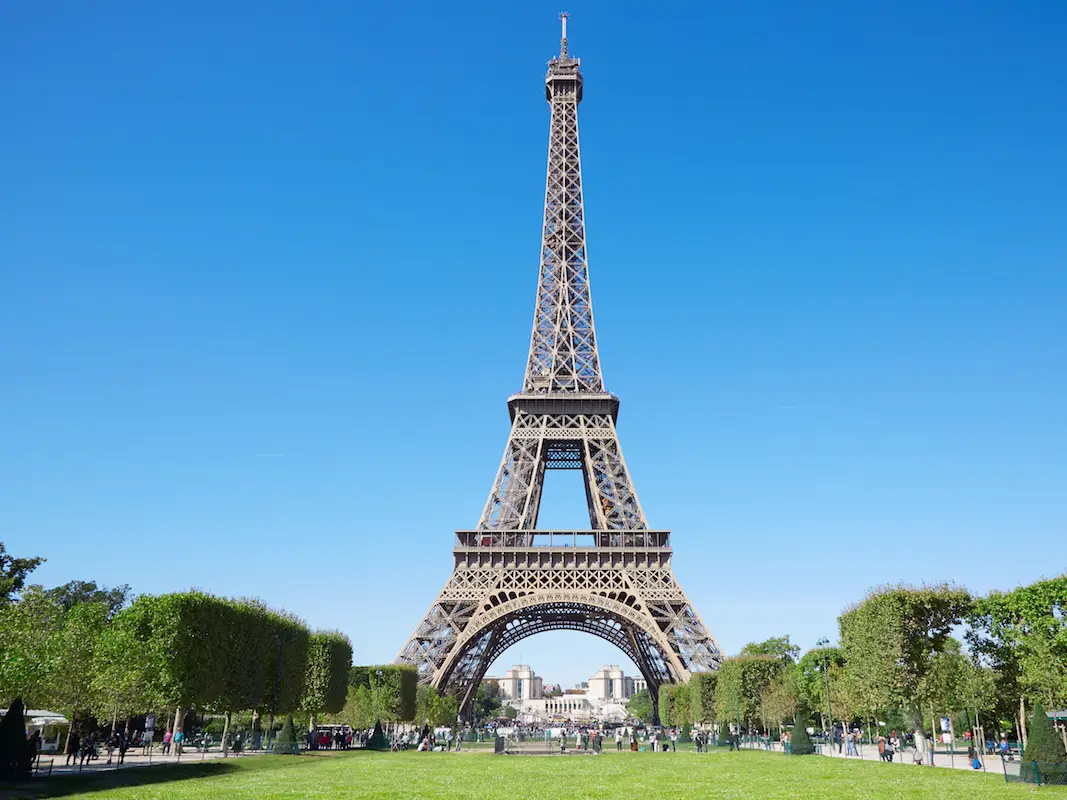Can you tell me about the history and significance of the Eiffel Tower? Certainly! The Eiffel Tower, completed in 1889 for the World's Fair in Paris, was initially criticized but has since become a global icon of France and a symbol of love and romance. Designed by Gustave Eiffel, it was the world's tallest building until the completion of the Chrysler Building in New York in 1930. Today, it attracts millions of visitors every year, who admire its unique structure and the panoramic views of Paris from its platforms. 